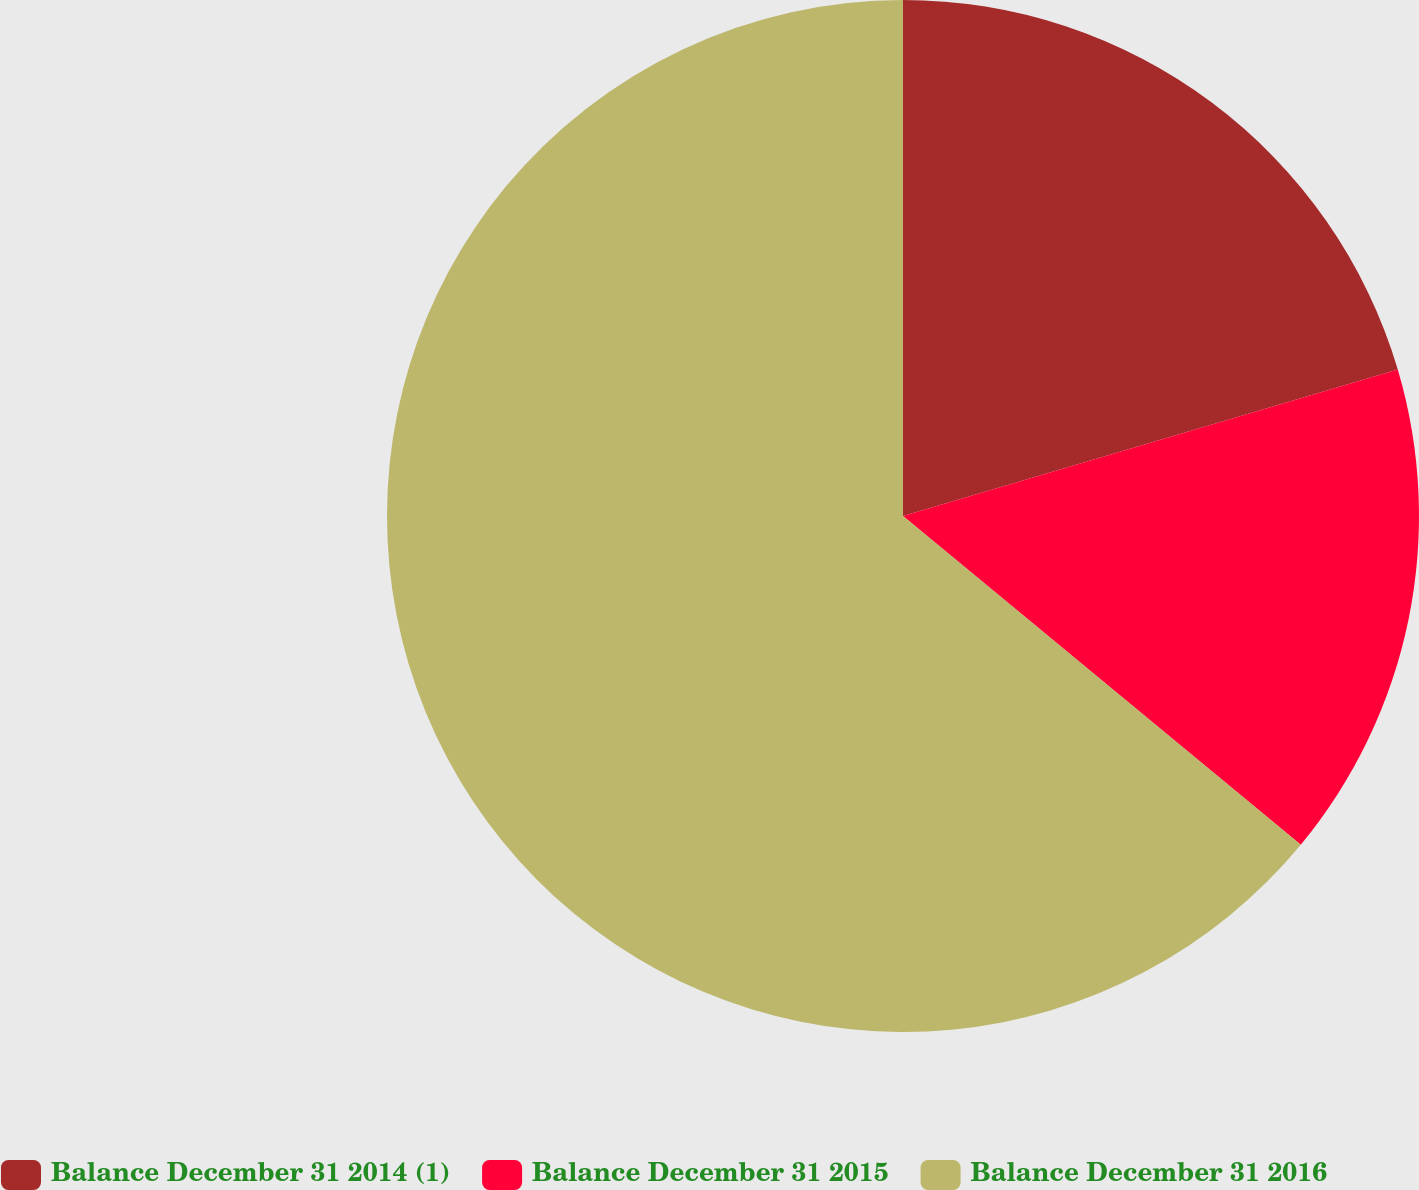<chart> <loc_0><loc_0><loc_500><loc_500><pie_chart><fcel>Balance December 31 2014 (1)<fcel>Balance December 31 2015<fcel>Balance December 31 2016<nl><fcel>20.42%<fcel>15.57%<fcel>64.01%<nl></chart> 